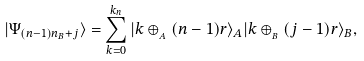<formula> <loc_0><loc_0><loc_500><loc_500>| \Psi _ { ( n - 1 ) n _ { B } + j } \rangle = \sum _ { k = 0 } ^ { k _ { n } } | k \oplus _ { _ { A } } ( n - 1 ) r \rangle _ { A } | k \oplus _ { _ { B } } ( j - 1 ) r \rangle _ { B } ,</formula> 